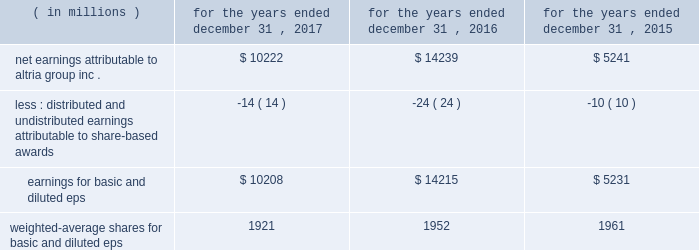10-k altria ar release tuesday , february 27 , 2018 10:00pm andra design llc performance stock units : in january 2017 , altria group , inc .
Granted an aggregate of 187886 performance stock units to eligible employees .
The payout of the performance stock units requires the achievement of certain performance measures , which were predetermined at the time of grant , over a three-year performance cycle .
These performance measures consist of altria group , inc . 2019s adjusted diluted earnings per share ( 201ceps 201d ) compounded annual growth rate and altria group , inc . 2019s total shareholder return relative to a predetermined peer group .
The performance stock units are also subject to forfeiture if certain employment conditions are not met .
At december 31 , 2017 , altria group , inc .
Had 170755 performance stock units remaining , with a weighted-average grant date fair value of $ 70.39 per performance stock unit .
The fair value of the performance stock units at the date of grant , net of estimated forfeitures , is amortized to expense over the performance period .
Altria group , inc .
Recorded pre-tax compensation expense related to performance stock units for the year ended december 31 , 2017 of $ 6 million .
The unamortized compensation expense related to altria group , inc . 2019s performance stock units was $ 7 million at december 31 , 2017 .
Altria group , inc .
Did not grant any performance stock units during 2016 and 2015 .
Note 12 .
Earnings per share basic and diluted eps were calculated using the following: .
Net earnings attributable to altria group , inc .
$ 10222 $ 14239 $ 5241 less : distributed and undistributed earnings attributable to share-based awards ( 14 ) ( 24 ) ( 10 ) earnings for basic and diluted eps $ 10208 $ 14215 $ 5231 weighted-average shares for basic and diluted eps 1921 1952 1961 .
What is the percent change in net earnings attributable to altria group inc . from 2016 to 2017? 
Computations: ((14239 - 10222) / 10222)
Answer: 0.39298. 